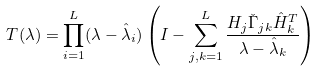Convert formula to latex. <formula><loc_0><loc_0><loc_500><loc_500>T ( \lambda ) = \prod _ { i = 1 } ^ { L } ( \lambda - \hat { \lambda } _ { i } ) \left ( I - \sum _ { j , k = 1 } ^ { L } \frac { H _ { j } \check { \Gamma } _ { j k } \hat { H } _ { k } ^ { T } } { \lambda - \hat { \lambda } _ { k } } \right )</formula> 